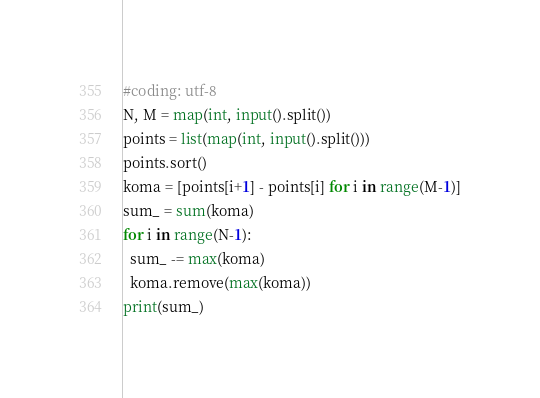Convert code to text. <code><loc_0><loc_0><loc_500><loc_500><_Python_>#coding: utf-8
N, M = map(int, input().split())
points = list(map(int, input().split()))
points.sort()
koma = [points[i+1] - points[i] for i in range(M-1)]
sum_ = sum(koma)
for i in range(N-1):
  sum_ -= max(koma)
  koma.remove(max(koma))
print(sum_)</code> 